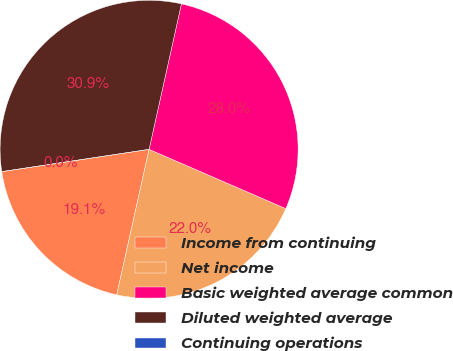Convert chart to OTSL. <chart><loc_0><loc_0><loc_500><loc_500><pie_chart><fcel>Income from continuing<fcel>Net income<fcel>Basic weighted average common<fcel>Diluted weighted average<fcel>Continuing operations<nl><fcel>19.13%<fcel>21.97%<fcel>28.03%<fcel>30.87%<fcel>0.0%<nl></chart> 